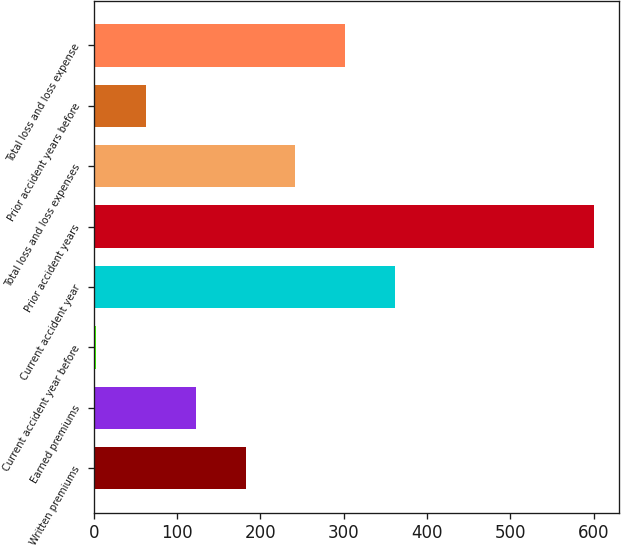Convert chart to OTSL. <chart><loc_0><loc_0><loc_500><loc_500><bar_chart><fcel>Written premiums<fcel>Earned premiums<fcel>Current accident year before<fcel>Current accident year<fcel>Prior accident years<fcel>Total loss and loss expenses<fcel>Prior accident years before<fcel>Total loss and loss expense<nl><fcel>182.1<fcel>122.4<fcel>3<fcel>361.2<fcel>600<fcel>241.8<fcel>62.7<fcel>301.5<nl></chart> 